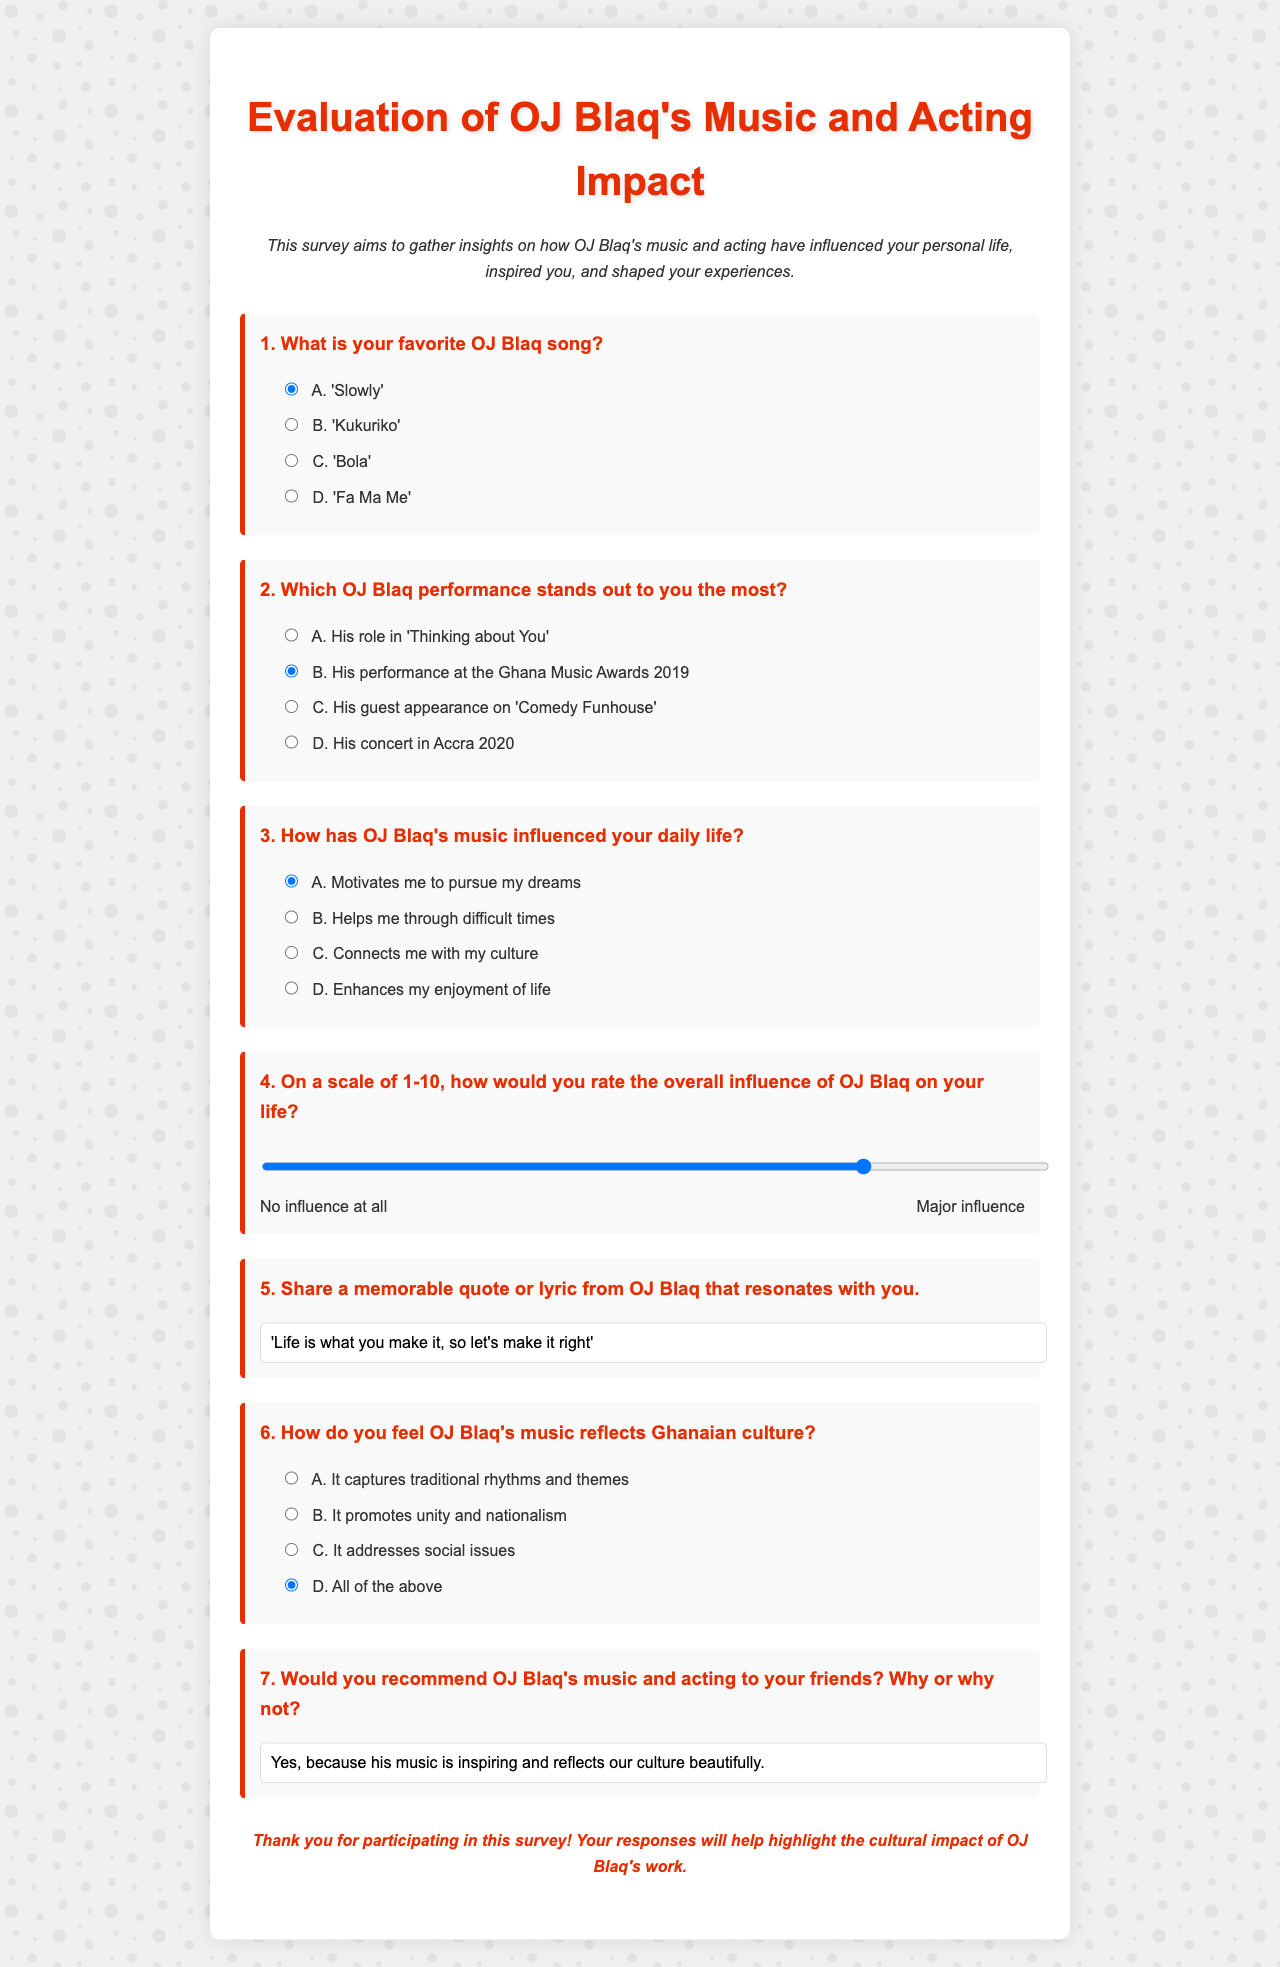What is the title of the survey? The title of the survey is found in the header of the document which reads "Evaluation of OJ Blaq's Music and Acting Impact."
Answer: Evaluation of OJ Blaq's Music and Acting Impact What is the first question in the survey? The first question appears at the beginning of the form, asking for the respondent's favorite OJ Blaq song.
Answer: What is your favorite OJ Blaq song? Which performance is marked as the most memorable by the respondents? The options for the second question include various performances, with the second option being the checked answer indicating it is the most memorable.
Answer: His performance at the Ghana Music Awards 2019 What rating scale is used to evaluate OJ Blaq's overall influence? The survey includes a rating scale ranging from 1 to 10 to assess the overall influence of OJ Blaq.
Answer: 1-10 What memorable quote from OJ Blaq is provided in the survey? The last question asks for a quote and supplies a value indicating a specific quote from OJ Blaq.
Answer: 'Life is what you make it, so let's make it right' How does the survey describe OJ Blaq's representation of Ghanaian culture? The survey has a question concerning the reflection of Ghanaian culture in OJ Blaq's music and offers options for responses.
Answer: All of the above What is the concluding remark in the survey? The closing lines express gratitude for the participation in the survey and highlight the intended use of the responses.
Answer: Thank you for participating in this survey! Your responses will help highlight the cultural impact of OJ Blaq's work 